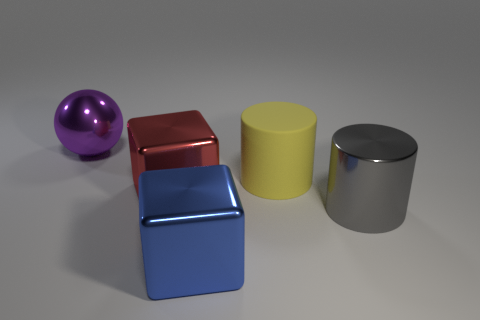There is a metal block that is to the left of the large blue metallic object; what is its size? The metal block to the left of the large blue object is relatively small in comparison. It appears to be a cube that could fit into a moderately sized hand, suggesting its dimensions might be close to that of a standard mug. 